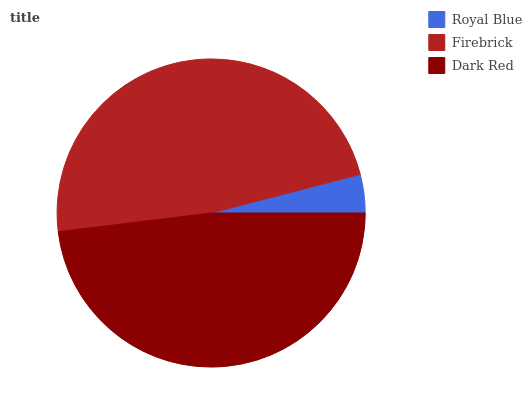Is Royal Blue the minimum?
Answer yes or no. Yes. Is Dark Red the maximum?
Answer yes or no. Yes. Is Firebrick the minimum?
Answer yes or no. No. Is Firebrick the maximum?
Answer yes or no. No. Is Firebrick greater than Royal Blue?
Answer yes or no. Yes. Is Royal Blue less than Firebrick?
Answer yes or no. Yes. Is Royal Blue greater than Firebrick?
Answer yes or no. No. Is Firebrick less than Royal Blue?
Answer yes or no. No. Is Firebrick the high median?
Answer yes or no. Yes. Is Firebrick the low median?
Answer yes or no. Yes. Is Dark Red the high median?
Answer yes or no. No. Is Royal Blue the low median?
Answer yes or no. No. 